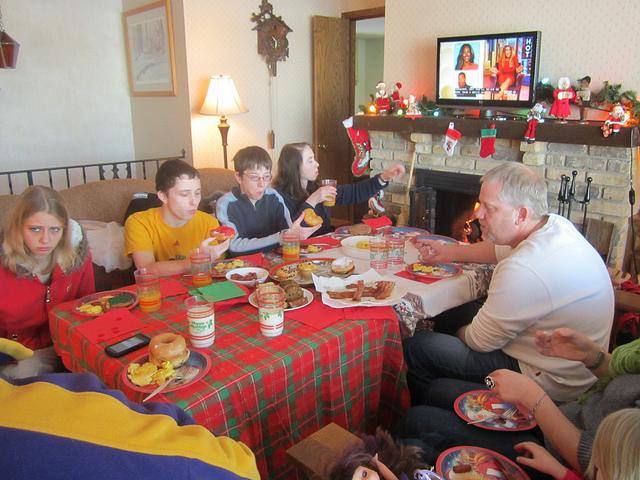What color is the cloth on the table?
Write a very short answer. Red and green. What is the white liquid in the glasses?
Concise answer only. Milk. What time of year does it appear to be?
Write a very short answer. Christmas. Are there more than two people in the photo?
Keep it brief. Yes. 